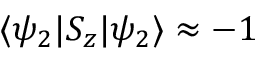Convert formula to latex. <formula><loc_0><loc_0><loc_500><loc_500>\langle \psi _ { 2 } | S _ { z } | \psi _ { 2 } \rangle \approx - 1</formula> 